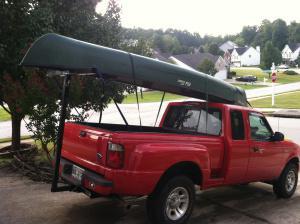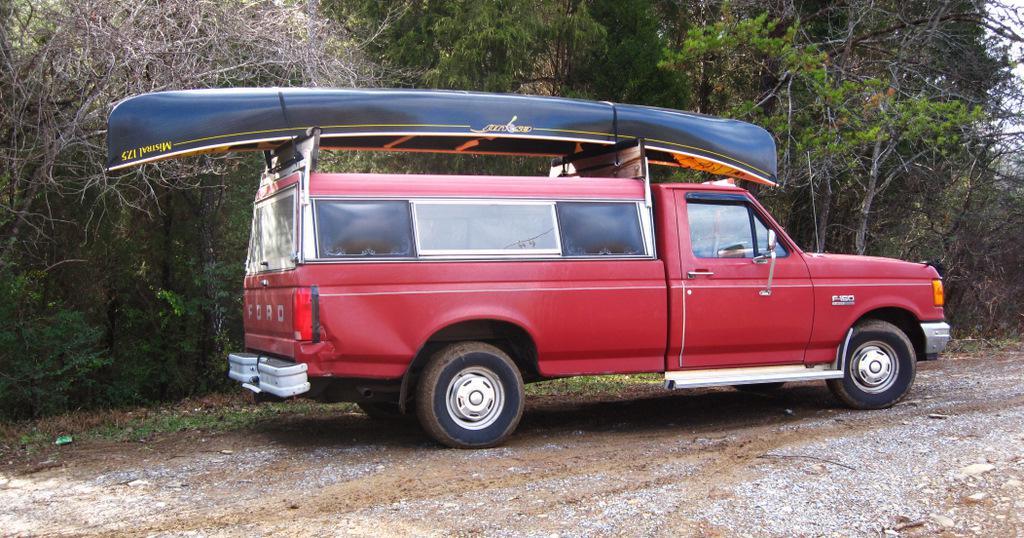The first image is the image on the left, the second image is the image on the right. Analyze the images presented: Is the assertion "All vehicles have a single boat secured to the roof." valid? Answer yes or no. Yes. 